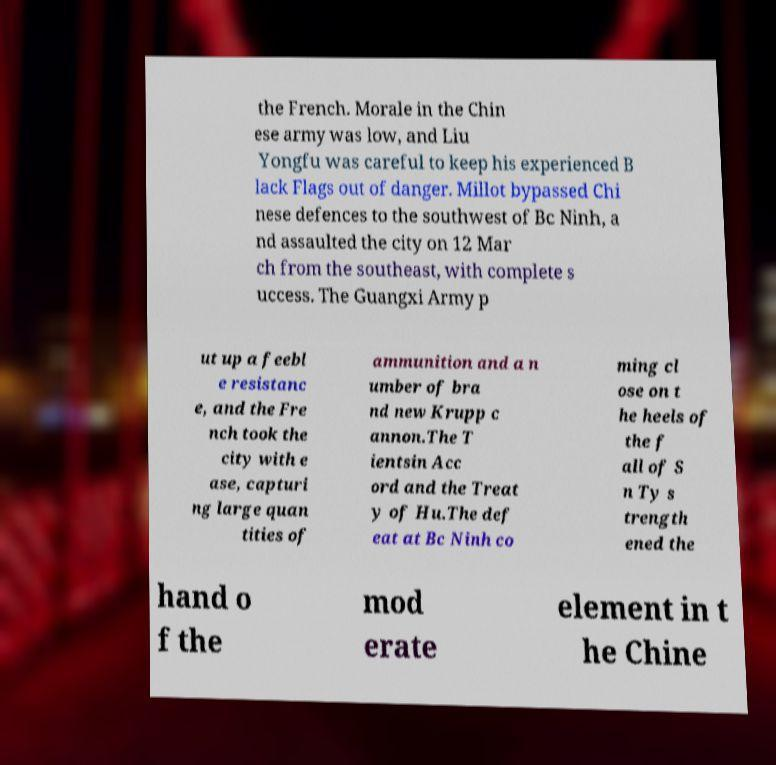Can you accurately transcribe the text from the provided image for me? the French. Morale in the Chin ese army was low, and Liu Yongfu was careful to keep his experienced B lack Flags out of danger. Millot bypassed Chi nese defences to the southwest of Bc Ninh, a nd assaulted the city on 12 Mar ch from the southeast, with complete s uccess. The Guangxi Army p ut up a feebl e resistanc e, and the Fre nch took the city with e ase, capturi ng large quan tities of ammunition and a n umber of bra nd new Krupp c annon.The T ientsin Acc ord and the Treat y of Hu.The def eat at Bc Ninh co ming cl ose on t he heels of the f all of S n Ty s trength ened the hand o f the mod erate element in t he Chine 